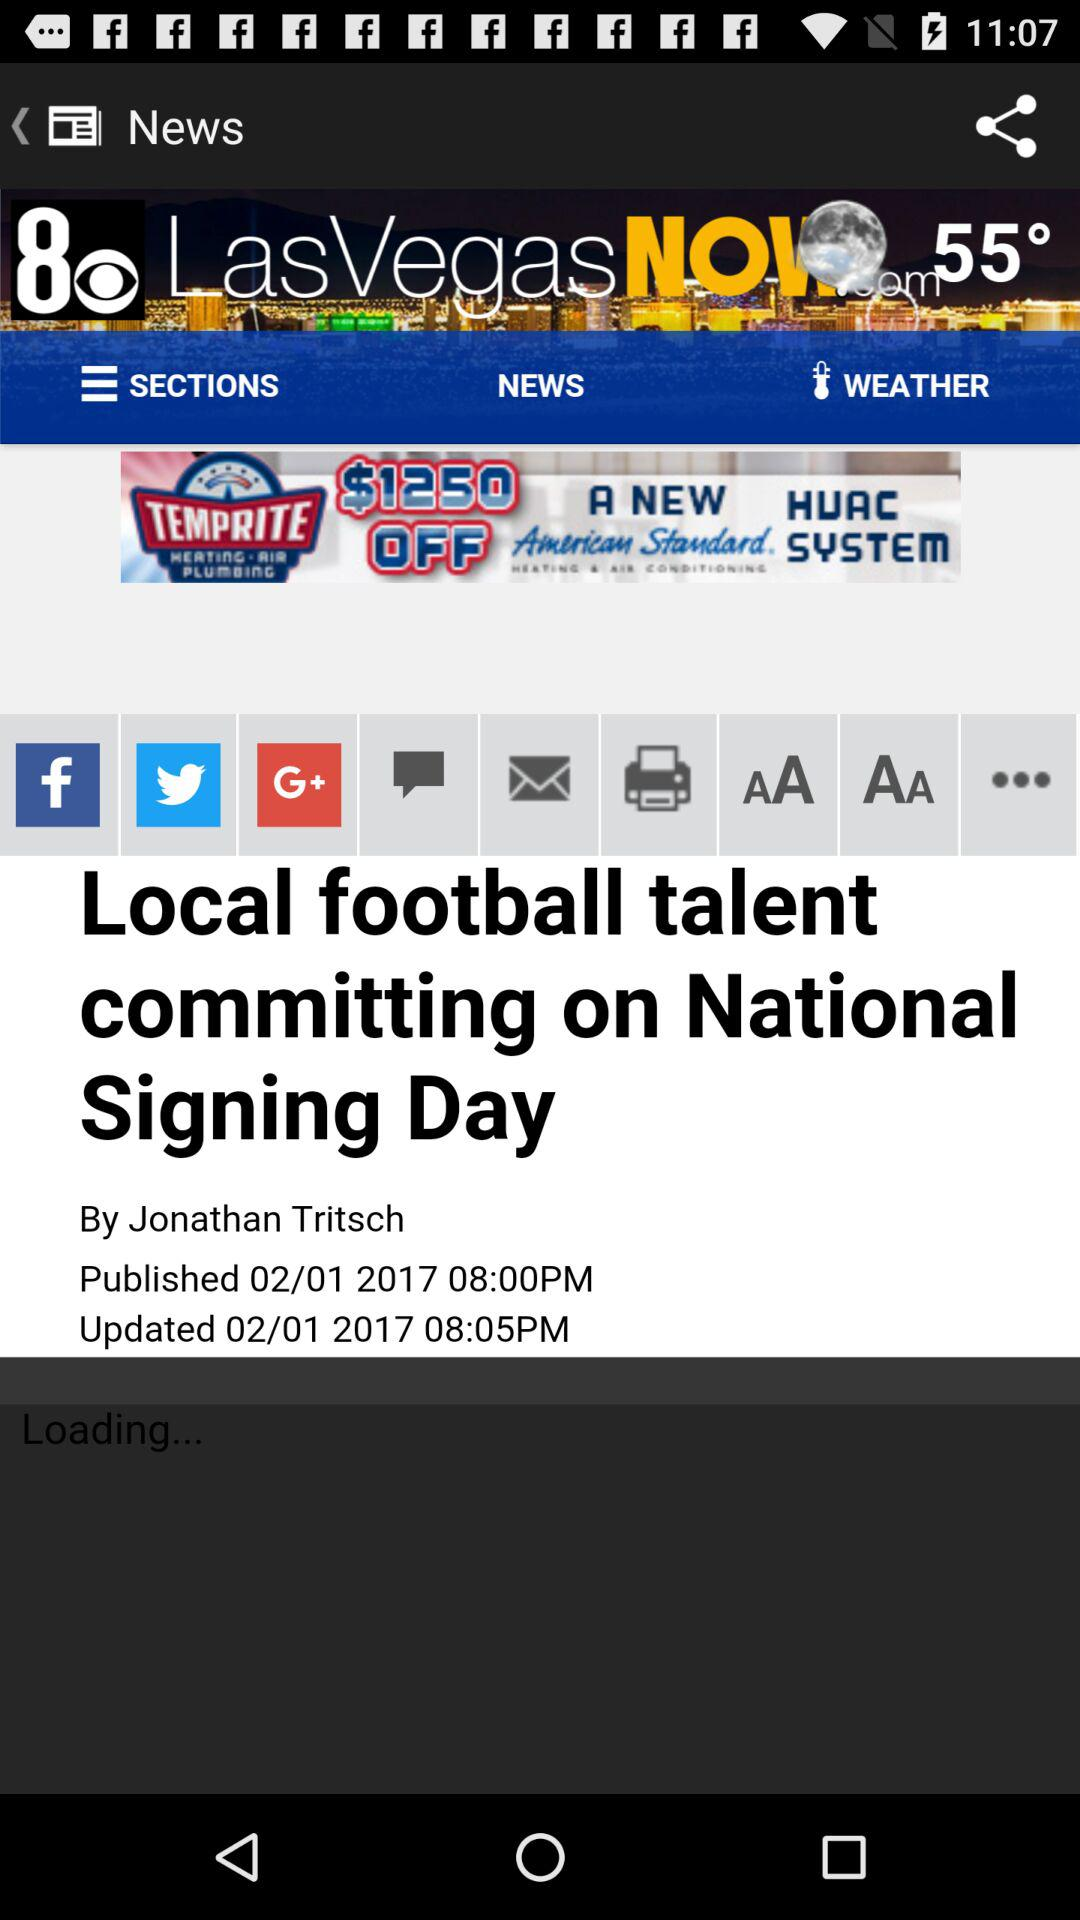What is the temperature? The temperature is 55°. 